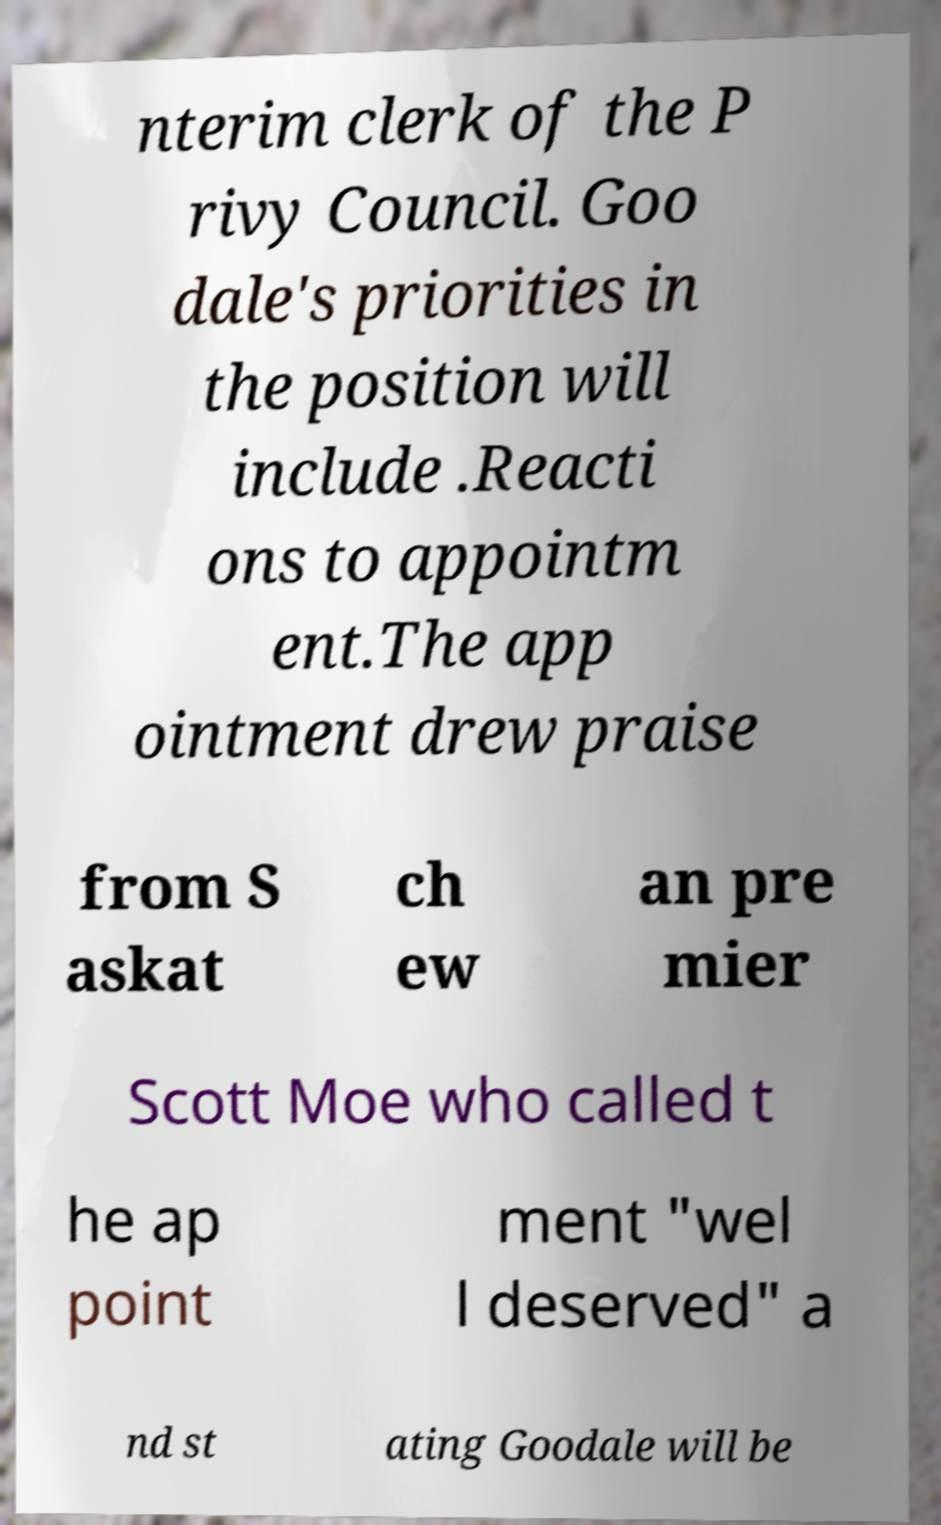Could you assist in decoding the text presented in this image and type it out clearly? nterim clerk of the P rivy Council. Goo dale's priorities in the position will include .Reacti ons to appointm ent.The app ointment drew praise from S askat ch ew an pre mier Scott Moe who called t he ap point ment "wel l deserved" a nd st ating Goodale will be 